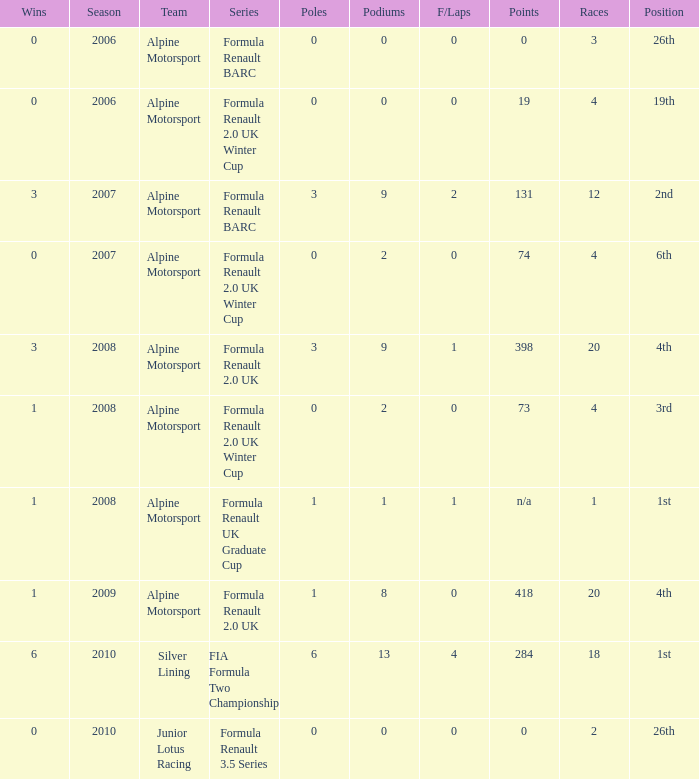What was the earliest season where podium was 9? 2007.0. 